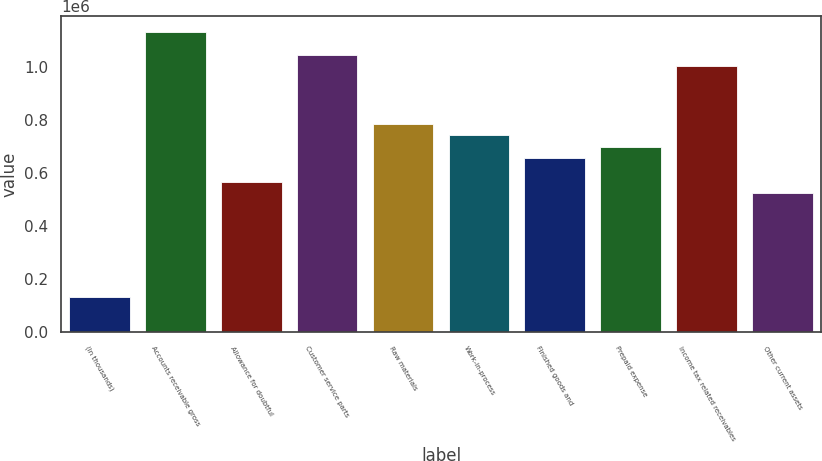Convert chart. <chart><loc_0><loc_0><loc_500><loc_500><bar_chart><fcel>(In thousands)<fcel>Accounts receivable gross<fcel>Allowance for doubtful<fcel>Customer service parts<fcel>Raw materials<fcel>Work-in-process<fcel>Finished goods and<fcel>Prepaid expense<fcel>Income tax related receivables<fcel>Other current assets<nl><fcel>131530<fcel>1.13222e+06<fcel>566613<fcel>1.0452e+06<fcel>784154<fcel>740646<fcel>653630<fcel>697138<fcel>1.0017e+06<fcel>523105<nl></chart> 